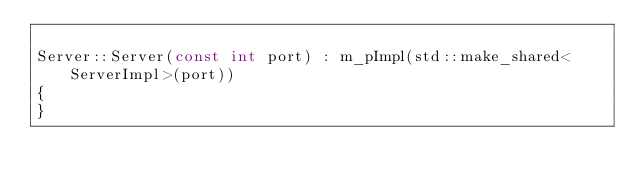<code> <loc_0><loc_0><loc_500><loc_500><_C++_>
Server::Server(const int port) : m_pImpl(std::make_shared<ServerImpl>(port))
{
}
</code> 